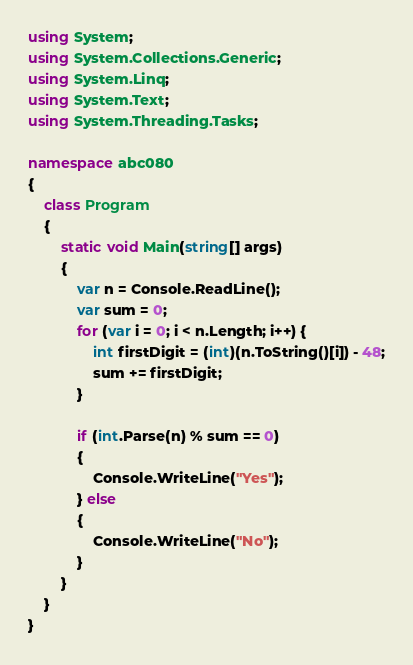<code> <loc_0><loc_0><loc_500><loc_500><_C#_>using System;
using System.Collections.Generic;
using System.Linq;
using System.Text;
using System.Threading.Tasks;

namespace abc080
{
    class Program
    {
        static void Main(string[] args)
        {
            var n = Console.ReadLine();
            var sum = 0;
            for (var i = 0; i < n.Length; i++) {
                int firstDigit = (int)(n.ToString()[i]) - 48;
                sum += firstDigit;
            }

            if (int.Parse(n) % sum == 0)
            {
                Console.WriteLine("Yes");
            } else
            {
                Console.WriteLine("No");
            }
        }
    }
}
</code> 